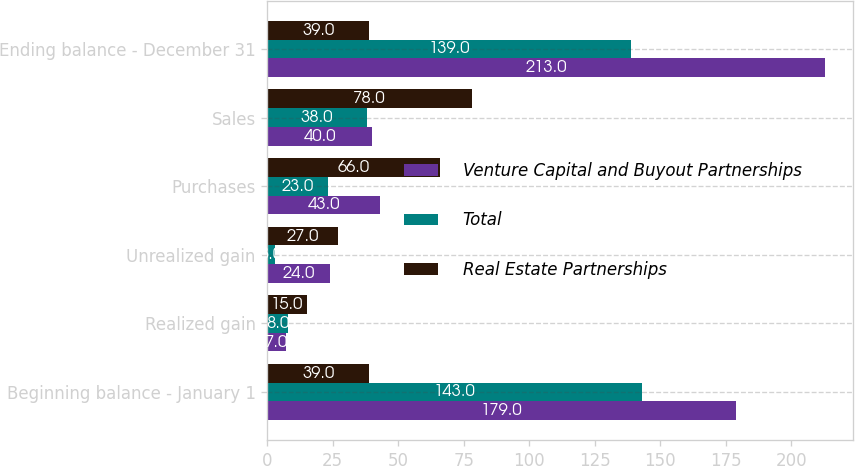<chart> <loc_0><loc_0><loc_500><loc_500><stacked_bar_chart><ecel><fcel>Beginning balance - January 1<fcel>Realized gain<fcel>Unrealized gain<fcel>Purchases<fcel>Sales<fcel>Ending balance - December 31<nl><fcel>Venture Capital and Buyout Partnerships<fcel>179<fcel>7<fcel>24<fcel>43<fcel>40<fcel>213<nl><fcel>Total<fcel>143<fcel>8<fcel>3<fcel>23<fcel>38<fcel>139<nl><fcel>Real Estate Partnerships<fcel>39<fcel>15<fcel>27<fcel>66<fcel>78<fcel>39<nl></chart> 